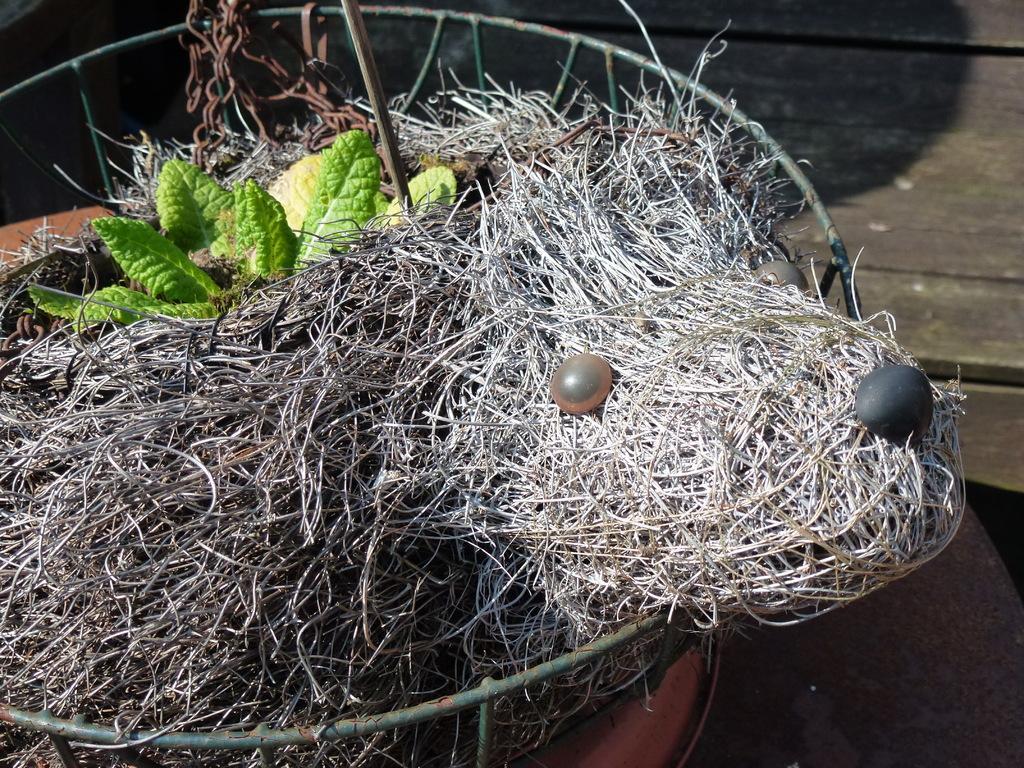Can you describe this image briefly? This image consists of a nest. In that there are two eggs. There are leaves at the top. 